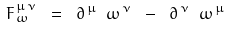<formula> <loc_0><loc_0><loc_500><loc_500>\ { F } _ { \, \omega } ^ { \, \mu \, \nu } \ = \ \partial ^ { \, \mu } \ { \omega } ^ { \, \nu } \ - \ \partial ^ { \, \nu } \ { \omega } ^ { \, \mu }</formula> 